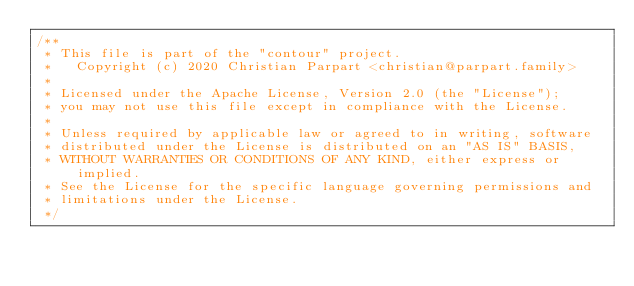Convert code to text. <code><loc_0><loc_0><loc_500><loc_500><_C_>/**
 * This file is part of the "contour" project.
 *   Copyright (c) 2020 Christian Parpart <christian@parpart.family>
 *
 * Licensed under the Apache License, Version 2.0 (the "License");
 * you may not use this file except in compliance with the License.
 *
 * Unless required by applicable law or agreed to in writing, software
 * distributed under the License is distributed on an "AS IS" BASIS,
 * WITHOUT WARRANTIES OR CONDITIONS OF ANY KIND, either express or implied.
 * See the License for the specific language governing permissions and
 * limitations under the License.
 */</code> 